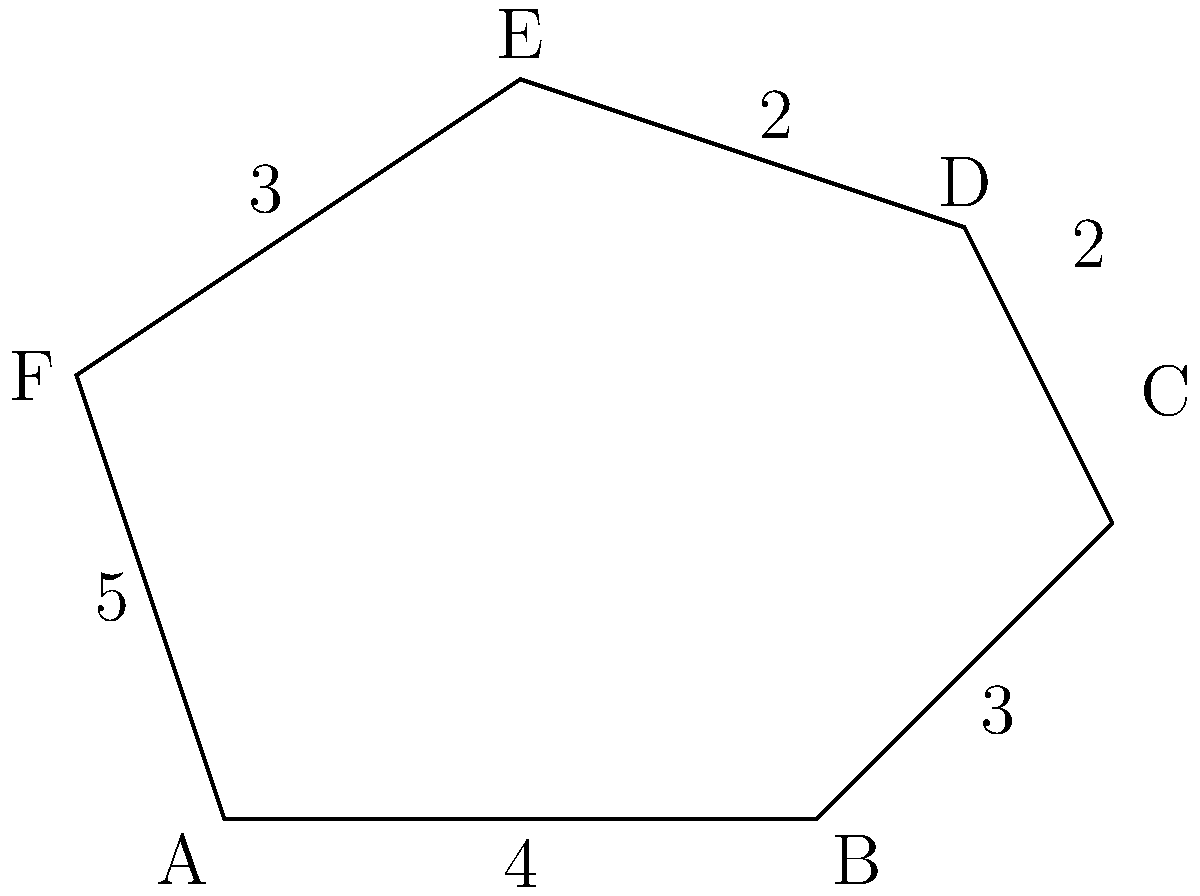In a neuroimaging study, an irregular polygon represents different brain regions. The lengths of the sides of this polygon are 4, 3, 2, 2, 3, and 5 units, as shown in the diagram. Calculate the perimeter of this polygon representing the brain regions. To calculate the perimeter of an irregular polygon, we need to sum up the lengths of all its sides. Let's break it down step by step:

1. Identify the lengths of all sides:
   Side AB = 4 units
   Side BC = 3 units
   Side CD = 2 units
   Side DE = 2 units
   Side EF = 3 units
   Side FA = 5 units

2. Set up the equation for the perimeter:
   $$ \text{Perimeter} = AB + BC + CD + DE + EF + FA $$

3. Substitute the known values:
   $$ \text{Perimeter} = 4 + 3 + 2 + 2 + 3 + 5 $$

4. Perform the addition:
   $$ \text{Perimeter} = 19 $$

Therefore, the perimeter of the irregular polygon representing the brain regions is 19 units.
Answer: 19 units 